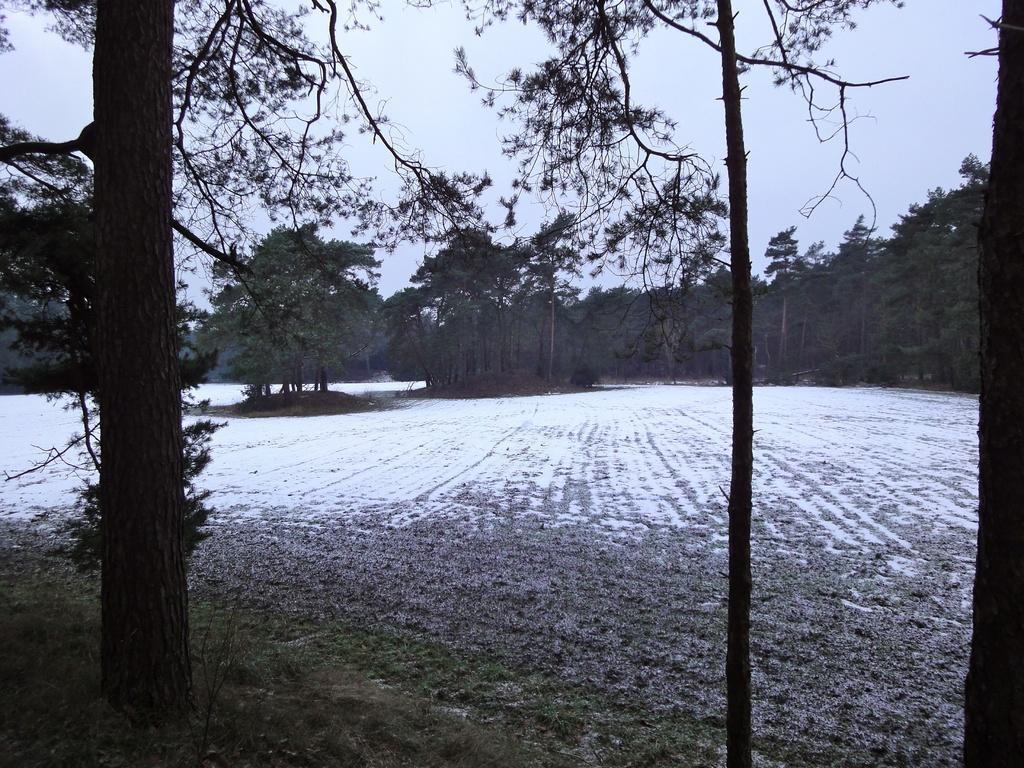In one or two sentences, can you explain what this image depicts? This image is clicked outside. At the bottom, there is a ground. In the background, there are many trees. At the top, there is a sky. 